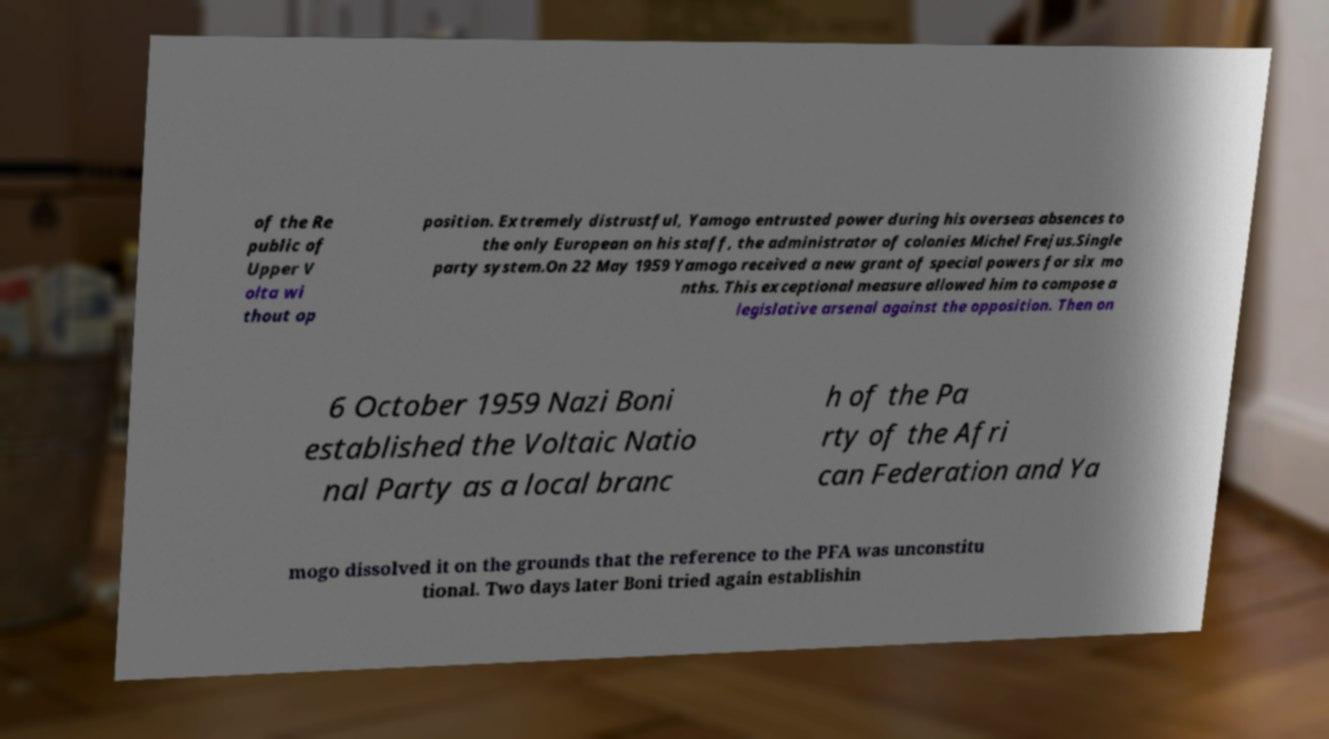Can you accurately transcribe the text from the provided image for me? of the Re public of Upper V olta wi thout op position. Extremely distrustful, Yamogo entrusted power during his overseas absences to the only European on his staff, the administrator of colonies Michel Frejus.Single party system.On 22 May 1959 Yamogo received a new grant of special powers for six mo nths. This exceptional measure allowed him to compose a legislative arsenal against the opposition. Then on 6 October 1959 Nazi Boni established the Voltaic Natio nal Party as a local branc h of the Pa rty of the Afri can Federation and Ya mogo dissolved it on the grounds that the reference to the PFA was unconstitu tional. Two days later Boni tried again establishin 